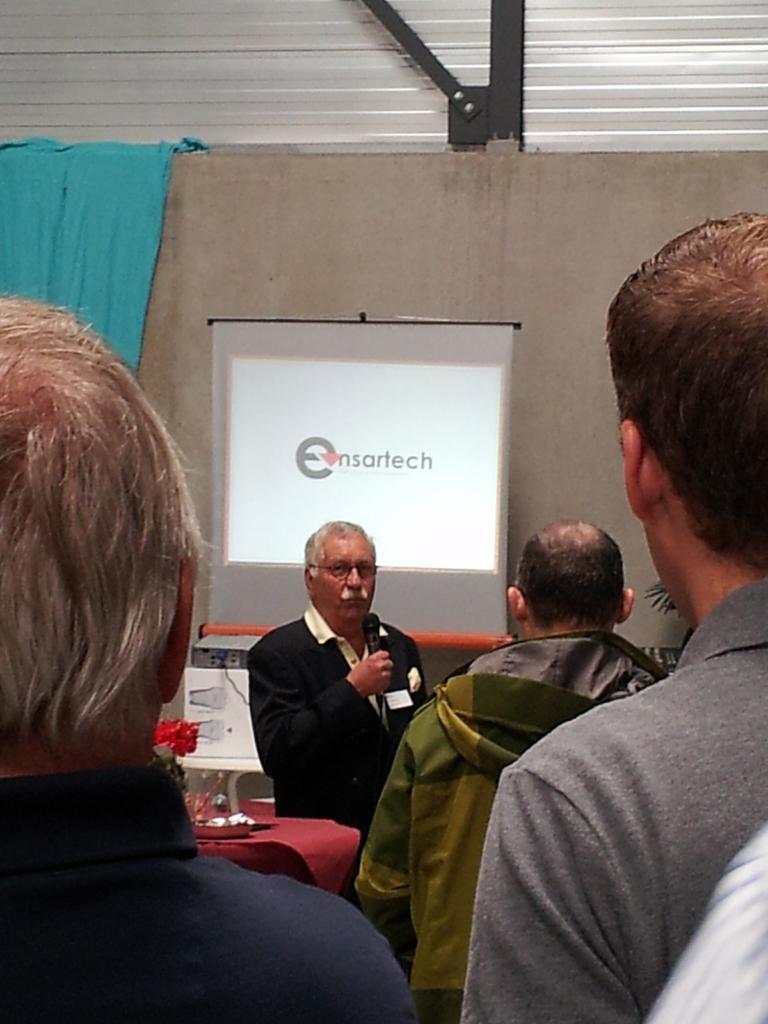Describe this image in one or two sentences. In this image I can see few people are standing and one person is holding a mic. Back I can see few objects, screen, wall and blue color cloth on the wall. 